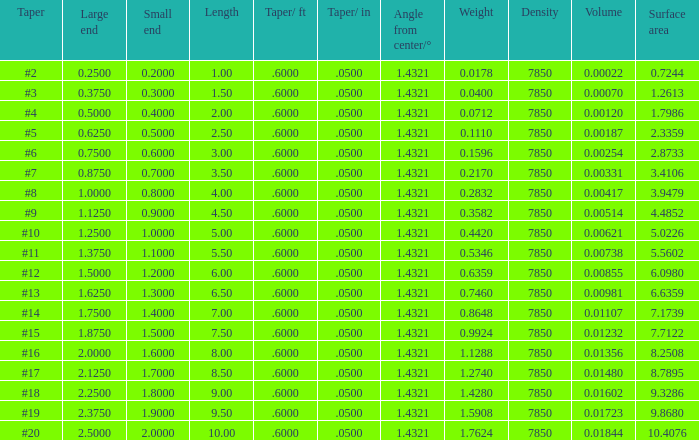Which Taper/ft that has a Large end smaller than 0.5, and a Taper of #2? 0.6. 